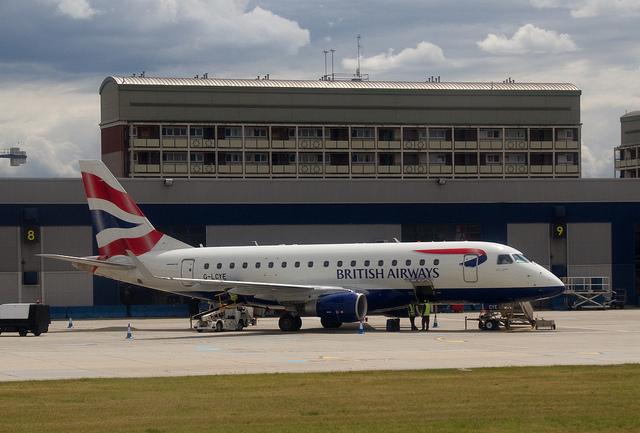How many planes are on the ground?
Concise answer only. 1. How many windows are on the airplane?
Answer briefly. 40. What airline does the plane belong to?
Concise answer only. British airways. How many people in neon vests?
Write a very short answer. 2. Where is this?
Short answer required. Airport. Is this plane leaving the runway?
Answer briefly. No. 